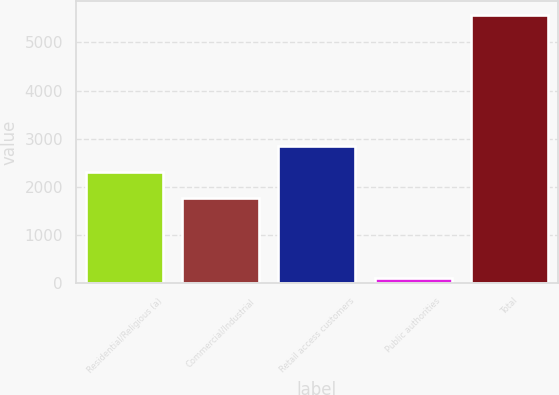<chart> <loc_0><loc_0><loc_500><loc_500><bar_chart><fcel>Residential/Religious (a)<fcel>Commercial/Industrial<fcel>Retail access customers<fcel>Public authorities<fcel>Total<nl><fcel>2309.3<fcel>1763<fcel>2855.6<fcel>111<fcel>5574<nl></chart> 